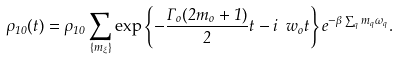<formula> <loc_0><loc_0><loc_500><loc_500>\rho _ { 1 0 } ( t ) = \rho _ { 1 0 } \sum _ { \{ m _ { \xi } \} } \exp \left \{ - \frac { \Gamma _ { o } ( 2 m _ { o } + 1 ) } { 2 } t - i \ w _ { o } t \right \} e ^ { - \beta \sum _ { q } m _ { q } \omega _ { q } } .</formula> 